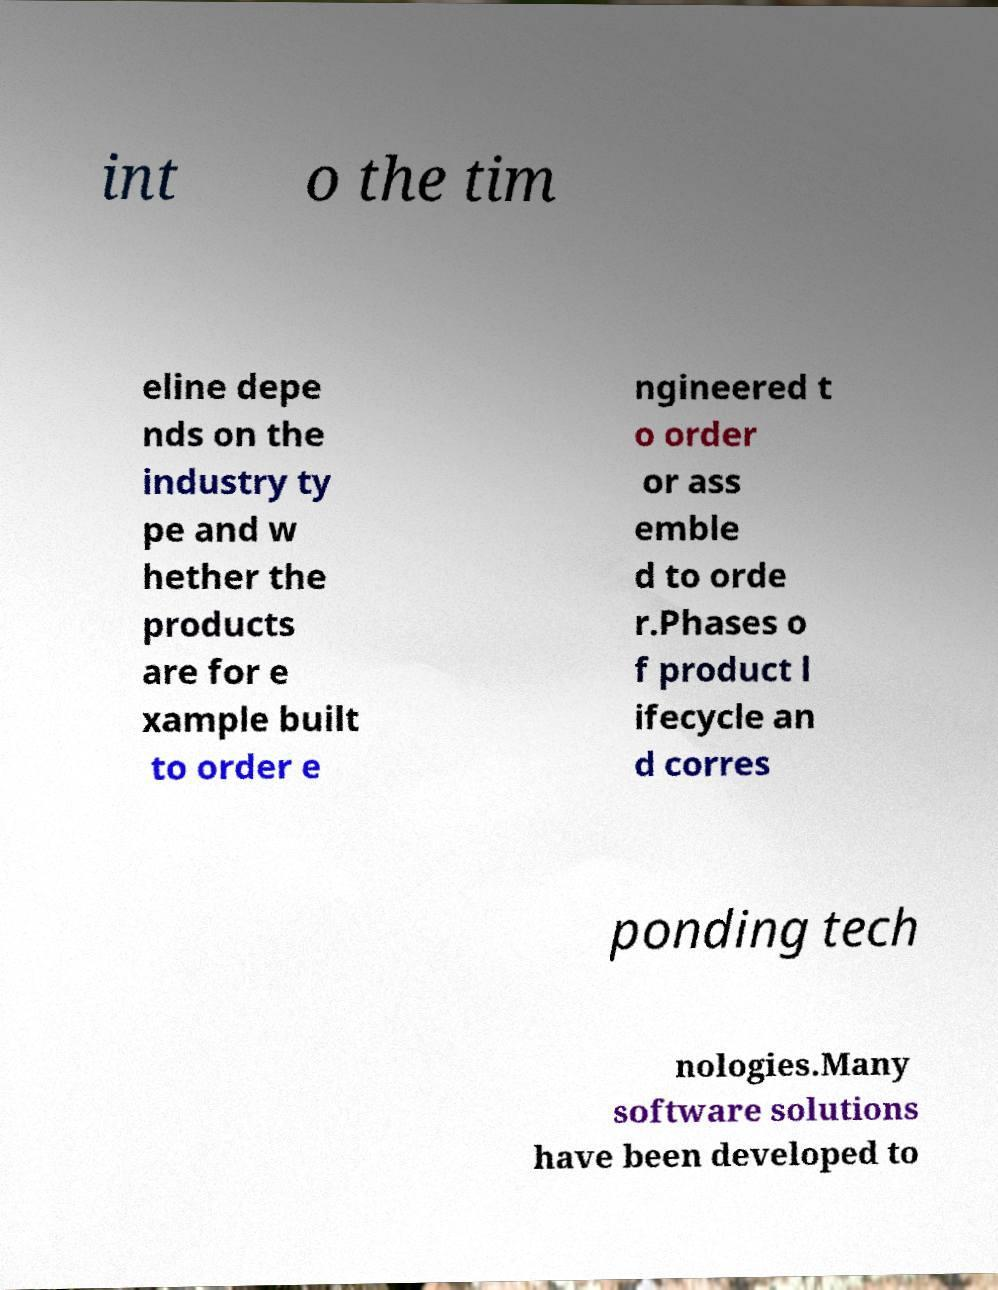For documentation purposes, I need the text within this image transcribed. Could you provide that? int o the tim eline depe nds on the industry ty pe and w hether the products are for e xample built to order e ngineered t o order or ass emble d to orde r.Phases o f product l ifecycle an d corres ponding tech nologies.Many software solutions have been developed to 